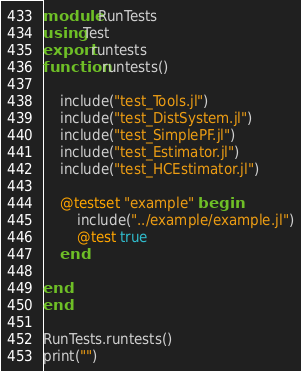<code> <loc_0><loc_0><loc_500><loc_500><_Julia_>module RunTests
using Test
export runtests
function runtests()

    include("test_Tools.jl")
    include("test_DistSystem.jl")
    include("test_SimplePF.jl")
    include("test_Estimator.jl")
    include("test_HCEstimator.jl")

    @testset "example" begin
        include("../example/example.jl")
        @test true
    end

end
end

RunTests.runtests()
print("")</code> 